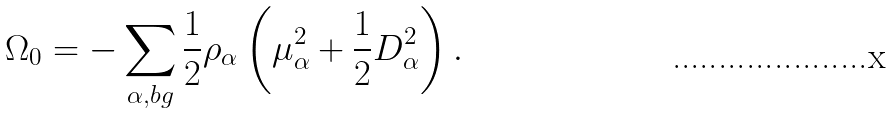Convert formula to latex. <formula><loc_0><loc_0><loc_500><loc_500>\Omega _ { 0 } = - \sum _ { \alpha , b g } \frac { 1 } { 2 } \rho _ { \alpha } \left ( \mu _ { \alpha } ^ { 2 } + \frac { 1 } { 2 } D _ { \alpha } ^ { 2 } \right ) .</formula> 